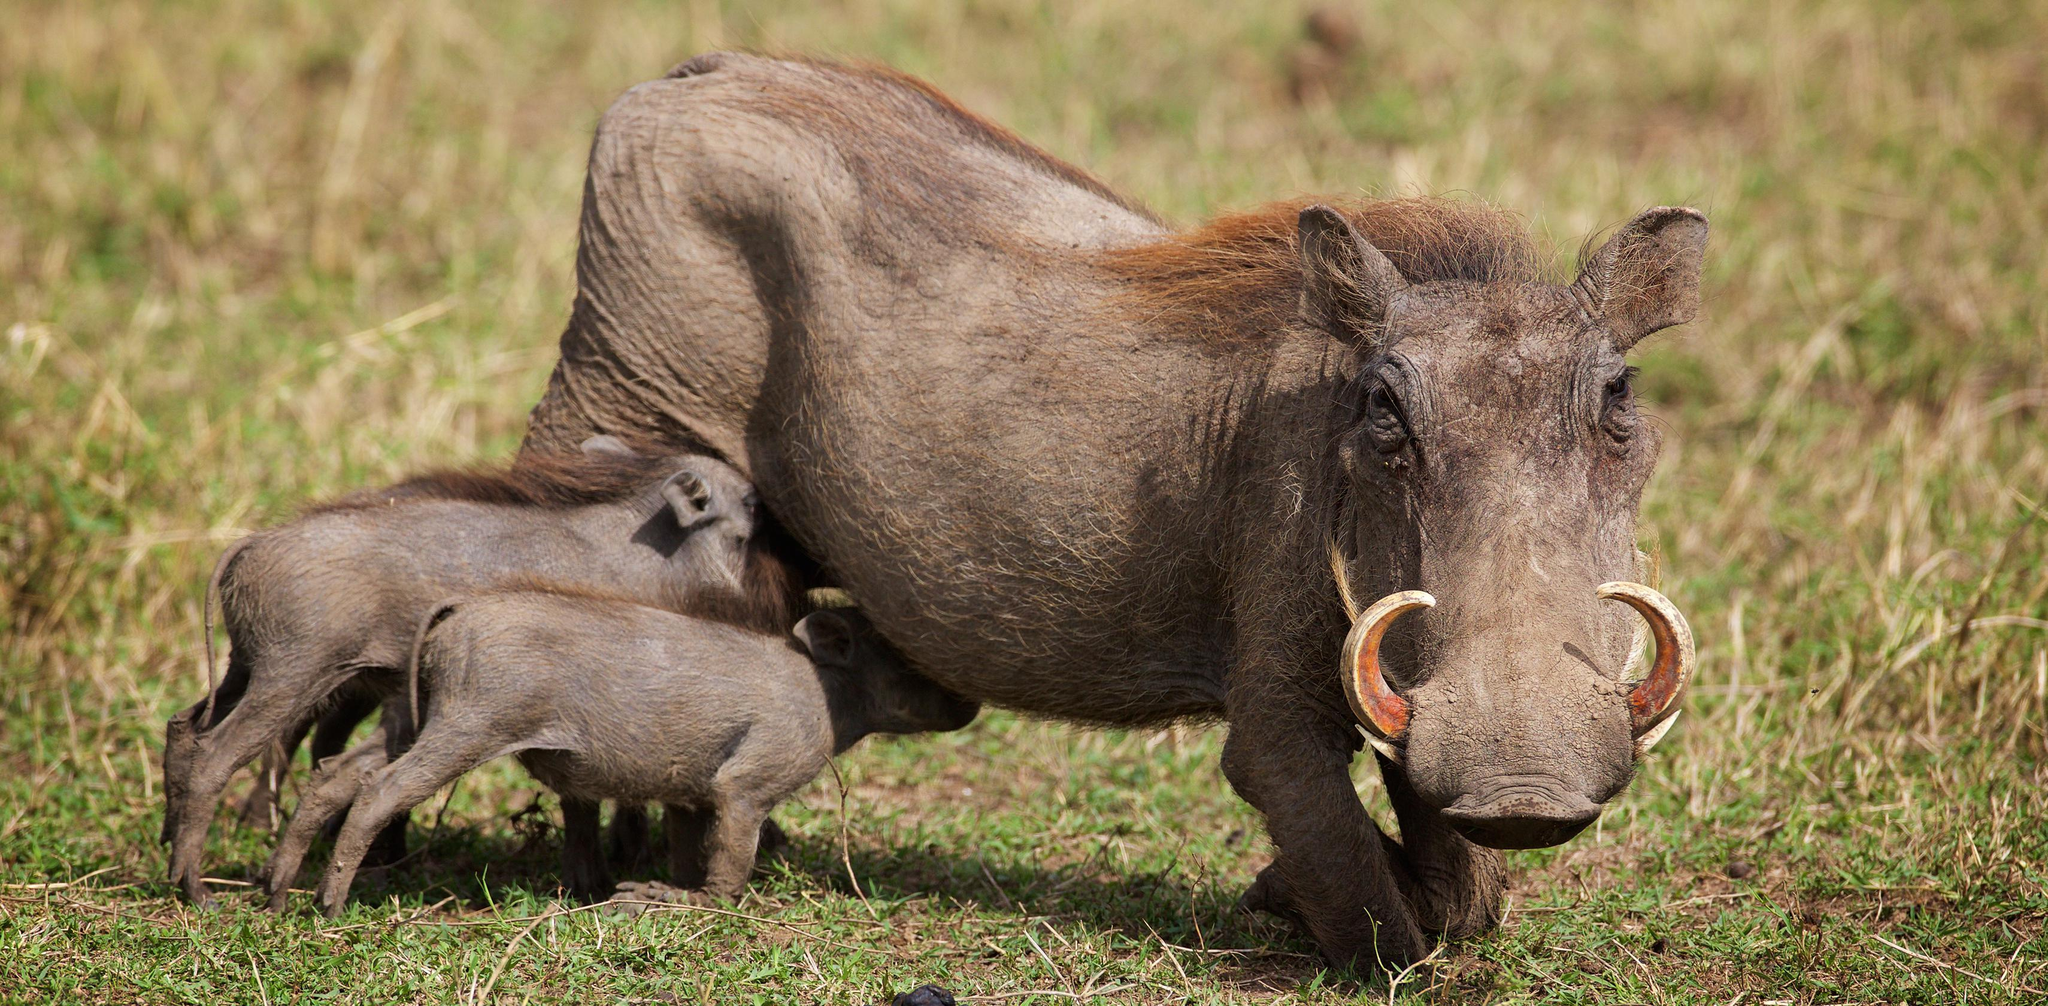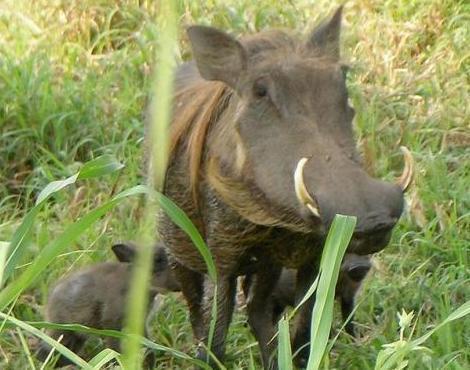The first image is the image on the left, the second image is the image on the right. Examine the images to the left and right. Is the description "There are two pairs of warthogs standing with their faces touching." accurate? Answer yes or no. No. The first image is the image on the left, the second image is the image on the right. For the images displayed, is the sentence "Both images show a pair of warthogs posed face-to-face." factually correct? Answer yes or no. No. 